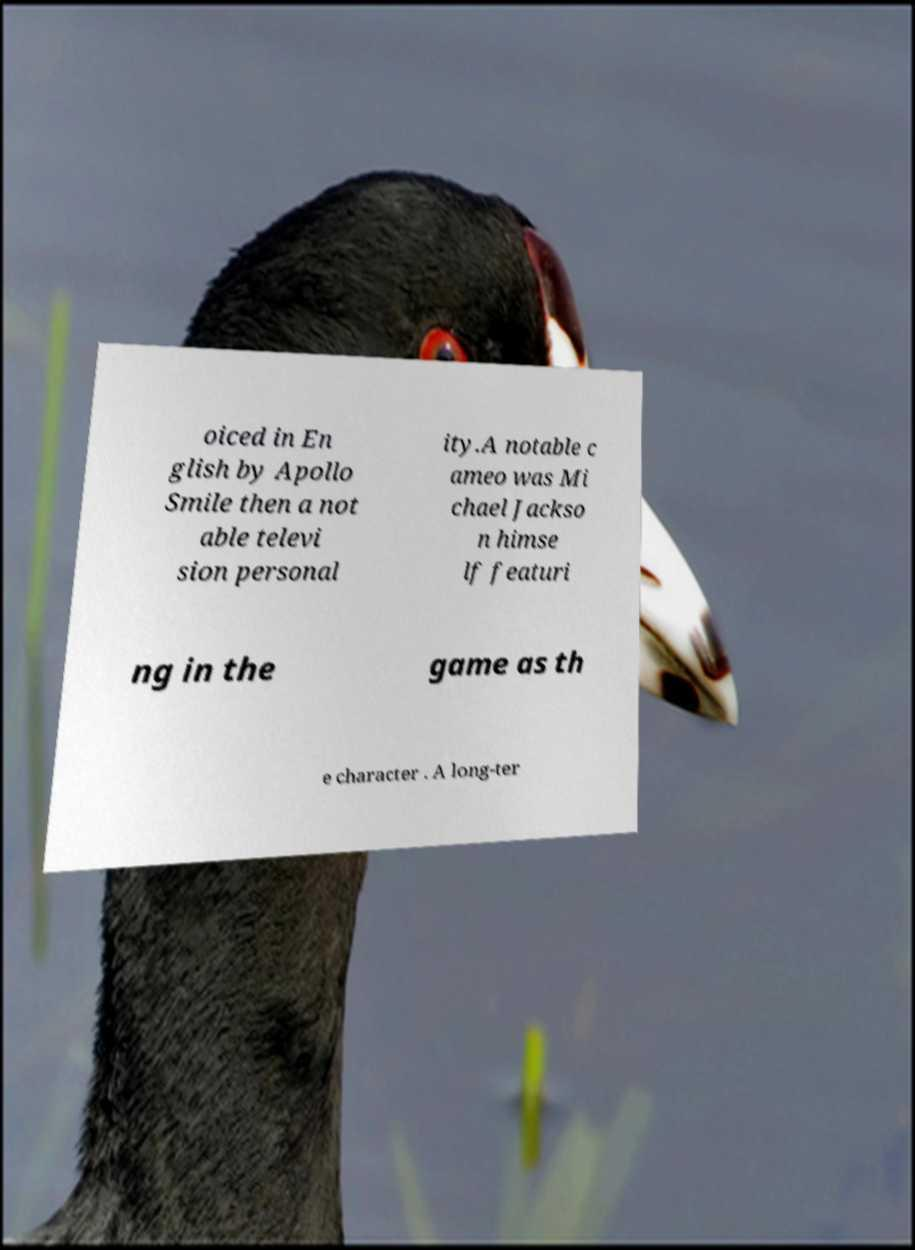What messages or text are displayed in this image? I need them in a readable, typed format. oiced in En glish by Apollo Smile then a not able televi sion personal ity.A notable c ameo was Mi chael Jackso n himse lf featuri ng in the game as th e character . A long-ter 